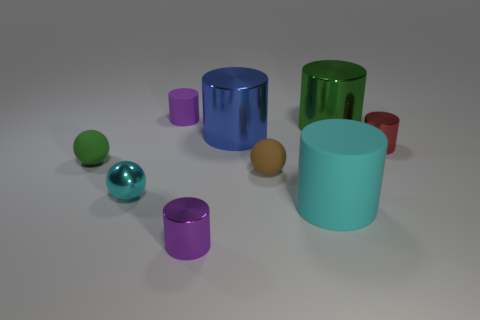Subtract all large blue cylinders. How many cylinders are left? 5 Subtract all green spheres. How many spheres are left? 2 Subtract all red balls. How many purple cylinders are left? 2 Subtract all cylinders. How many objects are left? 3 Subtract 2 cylinders. How many cylinders are left? 4 Add 8 small purple cylinders. How many small purple cylinders are left? 10 Add 5 tiny gray matte cylinders. How many tiny gray matte cylinders exist? 5 Subtract 0 blue balls. How many objects are left? 9 Subtract all gray balls. Subtract all brown blocks. How many balls are left? 3 Subtract all small brown matte objects. Subtract all brown rubber objects. How many objects are left? 7 